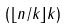<formula> <loc_0><loc_0><loc_500><loc_500>( \lfloor n / k \rfloor k )</formula> 